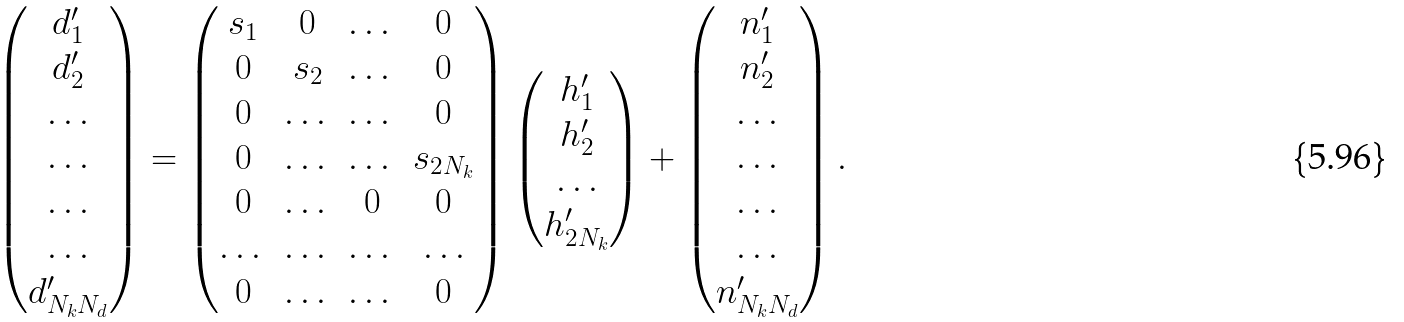Convert formula to latex. <formula><loc_0><loc_0><loc_500><loc_500>\left ( \begin{matrix} { d ^ { \prime } _ { 1 } } \\ { d ^ { \prime } _ { 2 } } \\ \dots \\ \dots \\ \dots \\ \dots \\ { d ^ { \prime } _ { N _ { k } N _ { d } } } \end{matrix} \right ) = \left ( \begin{matrix} s _ { 1 } & 0 & \dots & 0 \\ 0 & s _ { 2 } & \dots & 0 \\ 0 & \dots & \dots & 0 \\ 0 & \dots & \dots & s _ { 2 N _ { k } } \\ 0 & \dots & 0 & 0 \\ \dots & \dots & \dots & \dots \\ 0 & \dots & \dots & 0 \\ \end{matrix} \right ) \left ( \begin{matrix} { h ^ { \prime } _ { 1 } } \\ { h ^ { \prime } _ { 2 } } \\ \dots \\ h ^ { \prime } _ { 2 N _ { k } } \end{matrix} \right ) + \left ( \begin{matrix} { n ^ { \prime } _ { 1 } } \\ { n ^ { \prime } _ { 2 } } \\ \dots \\ \dots \\ \dots \\ \dots \\ { n ^ { \prime } _ { N _ { k } N _ { d } } } \end{matrix} \right ) .</formula> 